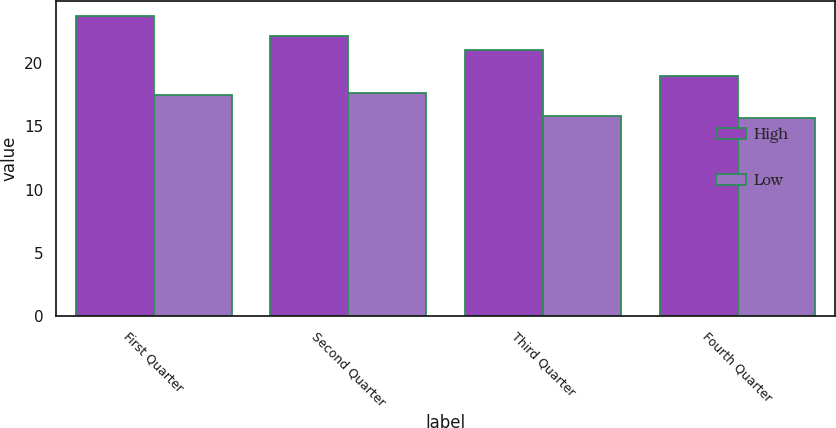Convert chart. <chart><loc_0><loc_0><loc_500><loc_500><stacked_bar_chart><ecel><fcel>First Quarter<fcel>Second Quarter<fcel>Third Quarter<fcel>Fourth Quarter<nl><fcel>High<fcel>23.76<fcel>22.14<fcel>21.05<fcel>18.99<nl><fcel>Low<fcel>17.48<fcel>17.68<fcel>15.86<fcel>15.7<nl></chart> 